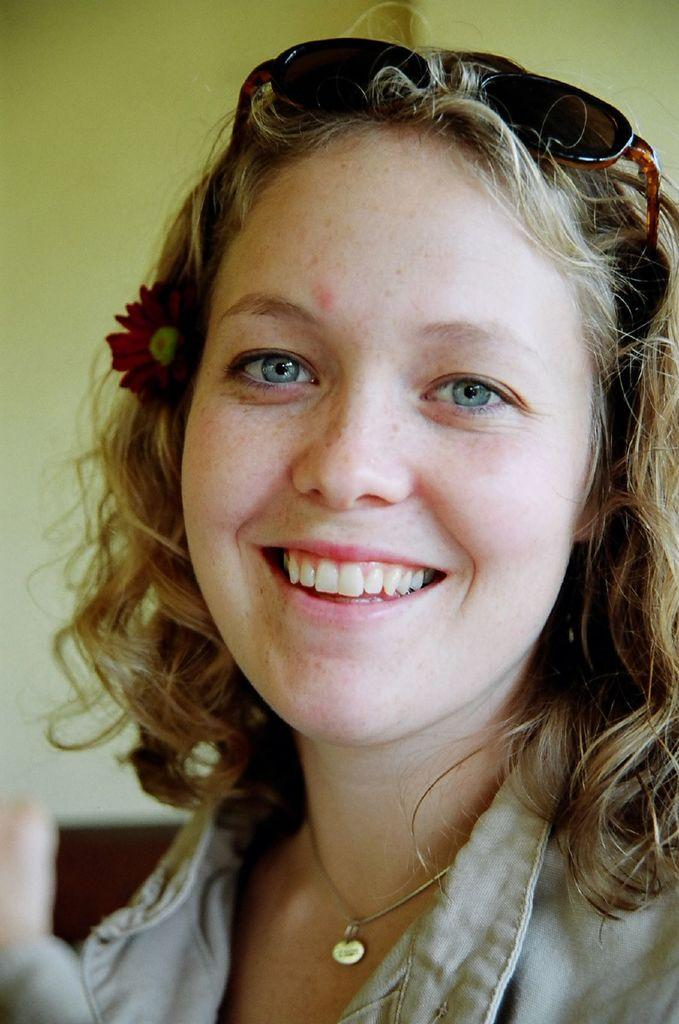Who is present in the image? There is a woman in the image. What is the woman wearing? The woman is wearing a coat. What expression does the woman have? The woman is smiling. What can be seen in the background of the image? There is a wall in the background of the image. What type of magic trick is the woman performing in the image? There is no indication in the image that the woman is performing a magic trick, so it cannot be determined from the picture. 